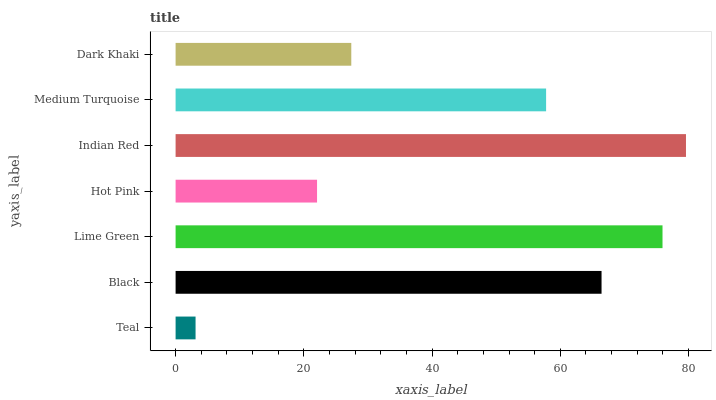Is Teal the minimum?
Answer yes or no. Yes. Is Indian Red the maximum?
Answer yes or no. Yes. Is Black the minimum?
Answer yes or no. No. Is Black the maximum?
Answer yes or no. No. Is Black greater than Teal?
Answer yes or no. Yes. Is Teal less than Black?
Answer yes or no. Yes. Is Teal greater than Black?
Answer yes or no. No. Is Black less than Teal?
Answer yes or no. No. Is Medium Turquoise the high median?
Answer yes or no. Yes. Is Medium Turquoise the low median?
Answer yes or no. Yes. Is Indian Red the high median?
Answer yes or no. No. Is Indian Red the low median?
Answer yes or no. No. 